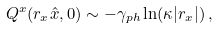<formula> <loc_0><loc_0><loc_500><loc_500>Q ^ { x } ( r _ { x } \hat { x } , 0 ) \sim - \gamma _ { p h } \ln ( \kappa | r _ { x } | ) \, ,</formula> 